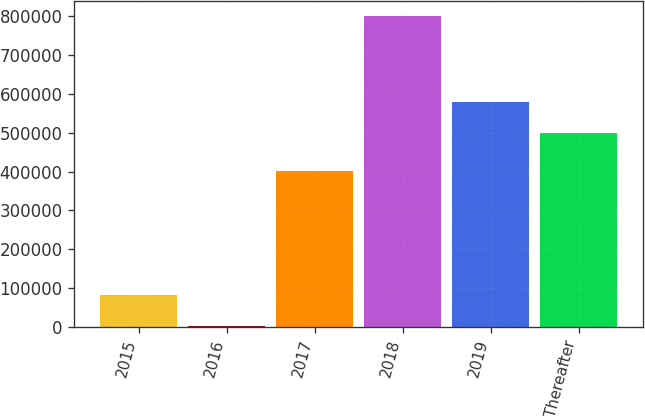Convert chart to OTSL. <chart><loc_0><loc_0><loc_500><loc_500><bar_chart><fcel>2015<fcel>2016<fcel>2017<fcel>2018<fcel>2019<fcel>Thereafter<nl><fcel>82105.4<fcel>2332<fcel>400630<fcel>800066<fcel>579773<fcel>500000<nl></chart> 